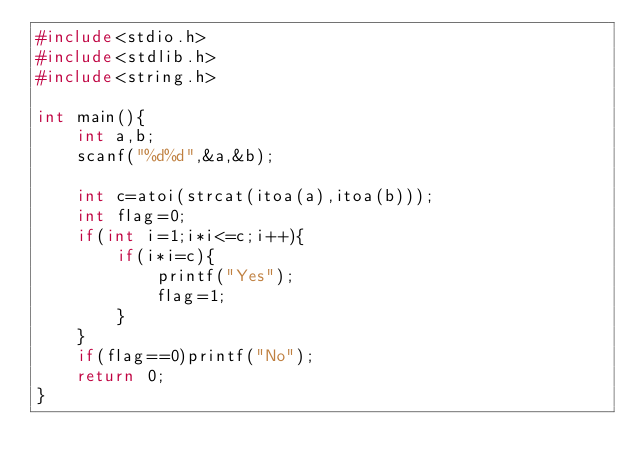<code> <loc_0><loc_0><loc_500><loc_500><_C_>#include<stdio.h>
#include<stdlib.h>
#include<string.h>

int main(){
    int a,b;
    scanf("%d%d",&a,&b);

    int c=atoi(strcat(itoa(a),itoa(b)));
    int flag=0;
    if(int i=1;i*i<=c;i++){
        if(i*i=c){
            printf("Yes");
            flag=1;
        }
    }
    if(flag==0)printf("No");
    return 0;
}</code> 